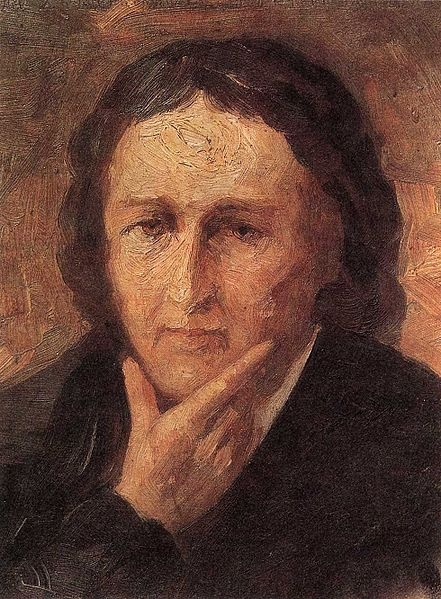Imagine this individual belongs to a different historical period. How might their attire or surroundings change in that context? Imagining this individual in a different historical period, let's place them in the Renaissance era. Their attire might change to rich, elaborate garments: perhaps a doublet and a velvet cloak for a nobleman or a richly embroidered gown for a noblewoman. The background might also transform into a finely detailed room of a grand estate, with tapestries and intricate woodwork, reflecting the opulence and artistic grandeur of the period. 